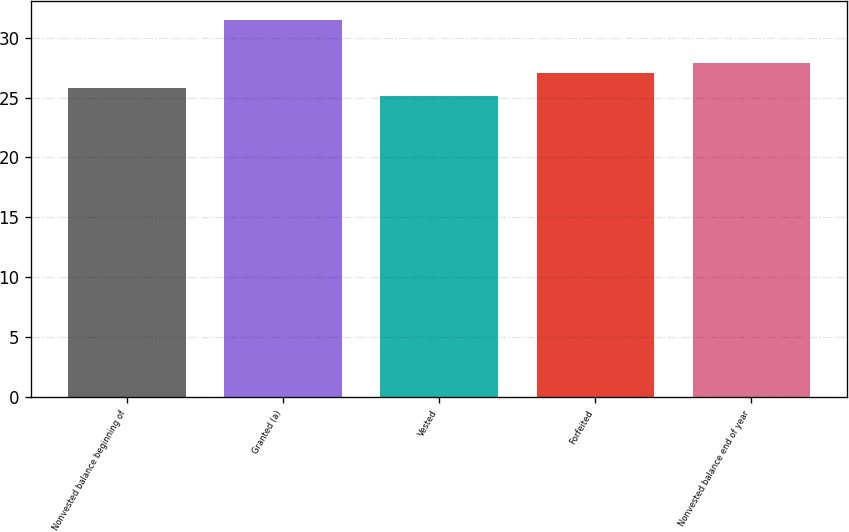Convert chart. <chart><loc_0><loc_0><loc_500><loc_500><bar_chart><fcel>Nonvested balance beginning of<fcel>Granted (a)<fcel>Vested<fcel>Forfeited<fcel>Nonvested balance end of year<nl><fcel>25.76<fcel>31.5<fcel>25.12<fcel>27.01<fcel>27.88<nl></chart> 